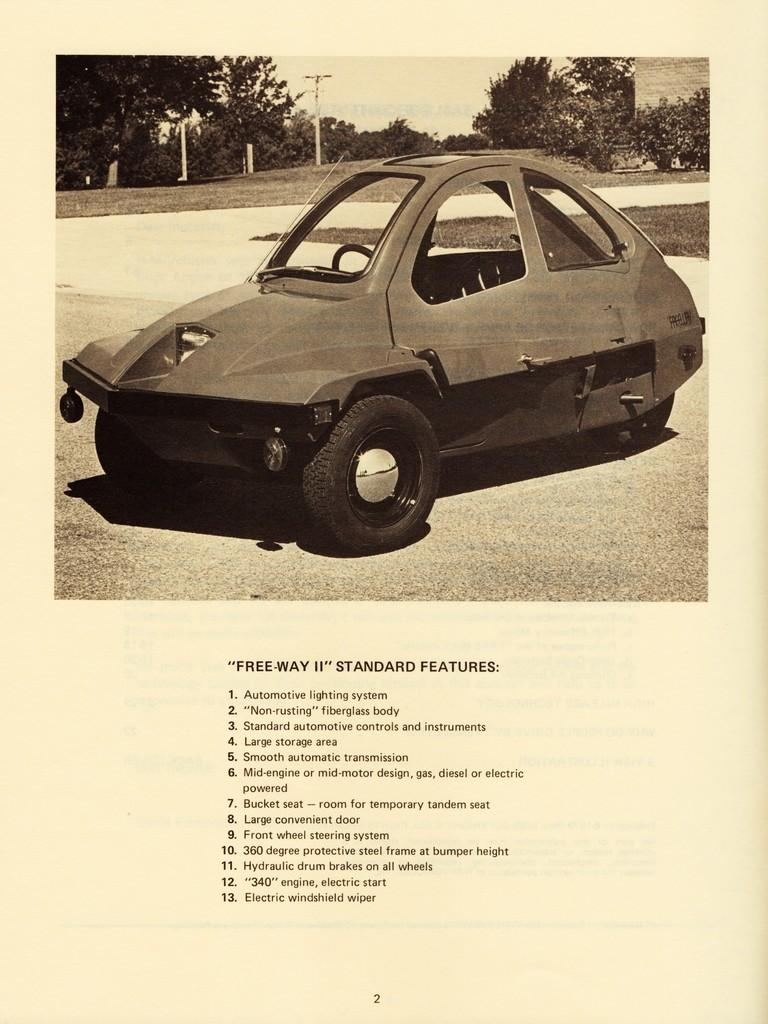What is the main subject of the image? There is a car in the image. What can be seen in the background of the image? Trees are present behind the car. Is there any text visible in the image? Yes, there is text written at the bottom of the image. What type of straw is being used to decorate the car in the image? There is no straw present in the image, and the car is not being decorated with any straw. 